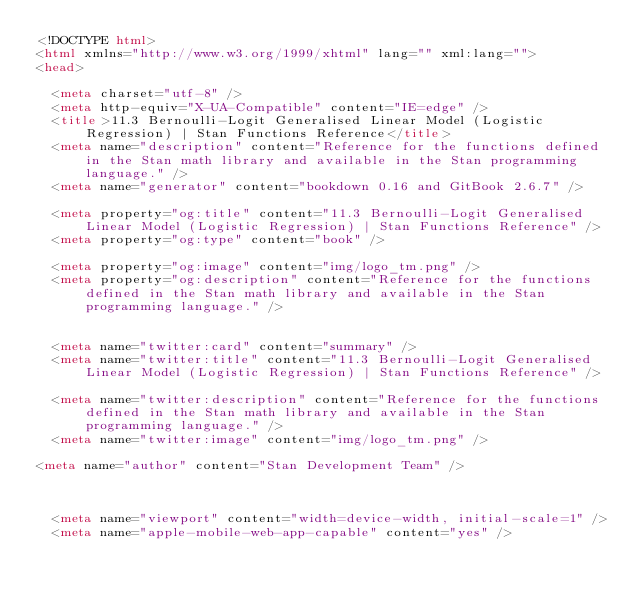<code> <loc_0><loc_0><loc_500><loc_500><_HTML_><!DOCTYPE html>
<html xmlns="http://www.w3.org/1999/xhtml" lang="" xml:lang="">
<head>

  <meta charset="utf-8" />
  <meta http-equiv="X-UA-Compatible" content="IE=edge" />
  <title>11.3 Bernoulli-Logit Generalised Linear Model (Logistic Regression) | Stan Functions Reference</title>
  <meta name="description" content="Reference for the functions defined in the Stan math library and available in the Stan programming language." />
  <meta name="generator" content="bookdown 0.16 and GitBook 2.6.7" />

  <meta property="og:title" content="11.3 Bernoulli-Logit Generalised Linear Model (Logistic Regression) | Stan Functions Reference" />
  <meta property="og:type" content="book" />
  
  <meta property="og:image" content="img/logo_tm.png" />
  <meta property="og:description" content="Reference for the functions defined in the Stan math library and available in the Stan programming language." />
  

  <meta name="twitter:card" content="summary" />
  <meta name="twitter:title" content="11.3 Bernoulli-Logit Generalised Linear Model (Logistic Regression) | Stan Functions Reference" />
  
  <meta name="twitter:description" content="Reference for the functions defined in the Stan math library and available in the Stan programming language." />
  <meta name="twitter:image" content="img/logo_tm.png" />

<meta name="author" content="Stan Development Team" />



  <meta name="viewport" content="width=device-width, initial-scale=1" />
  <meta name="apple-mobile-web-app-capable" content="yes" /></code> 